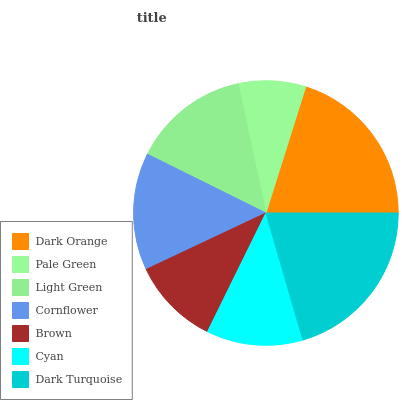Is Pale Green the minimum?
Answer yes or no. Yes. Is Dark Turquoise the maximum?
Answer yes or no. Yes. Is Light Green the minimum?
Answer yes or no. No. Is Light Green the maximum?
Answer yes or no. No. Is Light Green greater than Pale Green?
Answer yes or no. Yes. Is Pale Green less than Light Green?
Answer yes or no. Yes. Is Pale Green greater than Light Green?
Answer yes or no. No. Is Light Green less than Pale Green?
Answer yes or no. No. Is Light Green the high median?
Answer yes or no. Yes. Is Light Green the low median?
Answer yes or no. Yes. Is Brown the high median?
Answer yes or no. No. Is Dark Orange the low median?
Answer yes or no. No. 